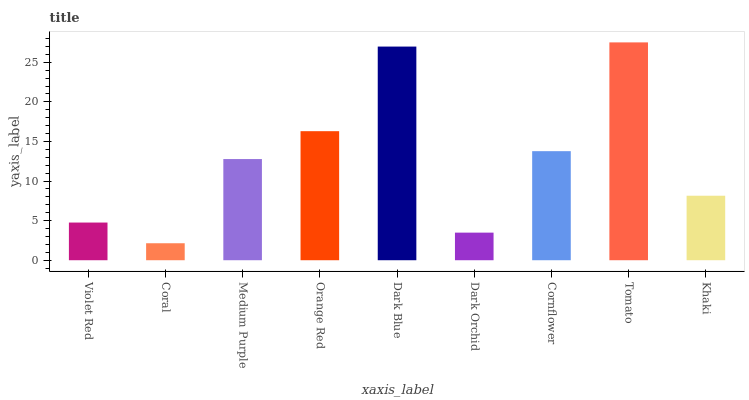Is Coral the minimum?
Answer yes or no. Yes. Is Tomato the maximum?
Answer yes or no. Yes. Is Medium Purple the minimum?
Answer yes or no. No. Is Medium Purple the maximum?
Answer yes or no. No. Is Medium Purple greater than Coral?
Answer yes or no. Yes. Is Coral less than Medium Purple?
Answer yes or no. Yes. Is Coral greater than Medium Purple?
Answer yes or no. No. Is Medium Purple less than Coral?
Answer yes or no. No. Is Medium Purple the high median?
Answer yes or no. Yes. Is Medium Purple the low median?
Answer yes or no. Yes. Is Orange Red the high median?
Answer yes or no. No. Is Orange Red the low median?
Answer yes or no. No. 